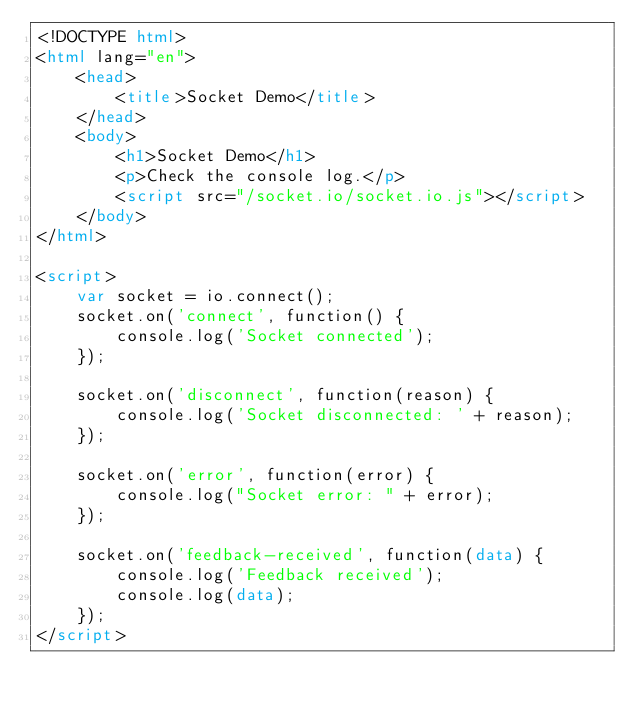<code> <loc_0><loc_0><loc_500><loc_500><_HTML_><!DOCTYPE html>  
<html lang="en">  
    <head>
        <title>Socket Demo</title>
    </head>
    <body>
        <h1>Socket Demo</h1>
        <p>Check the console log.</p>
        <script src="/socket.io/socket.io.js"></script>
    </body>
</html>

<script>
    var socket = io.connect();
    socket.on('connect', function() {
        console.log('Socket connected');
    });

    socket.on('disconnect', function(reason) {
        console.log('Socket disconnected: ' + reason);
    });

    socket.on('error', function(error) {
        console.log("Socket error: " + error);
    });

    socket.on('feedback-received', function(data) {
        console.log('Feedback received');
        console.log(data);
    });
</script></code> 